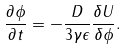<formula> <loc_0><loc_0><loc_500><loc_500>\frac { \partial \phi } { \partial t } = - \frac { D } { 3 \gamma \epsilon } \frac { \delta U } { \delta \phi } .</formula> 